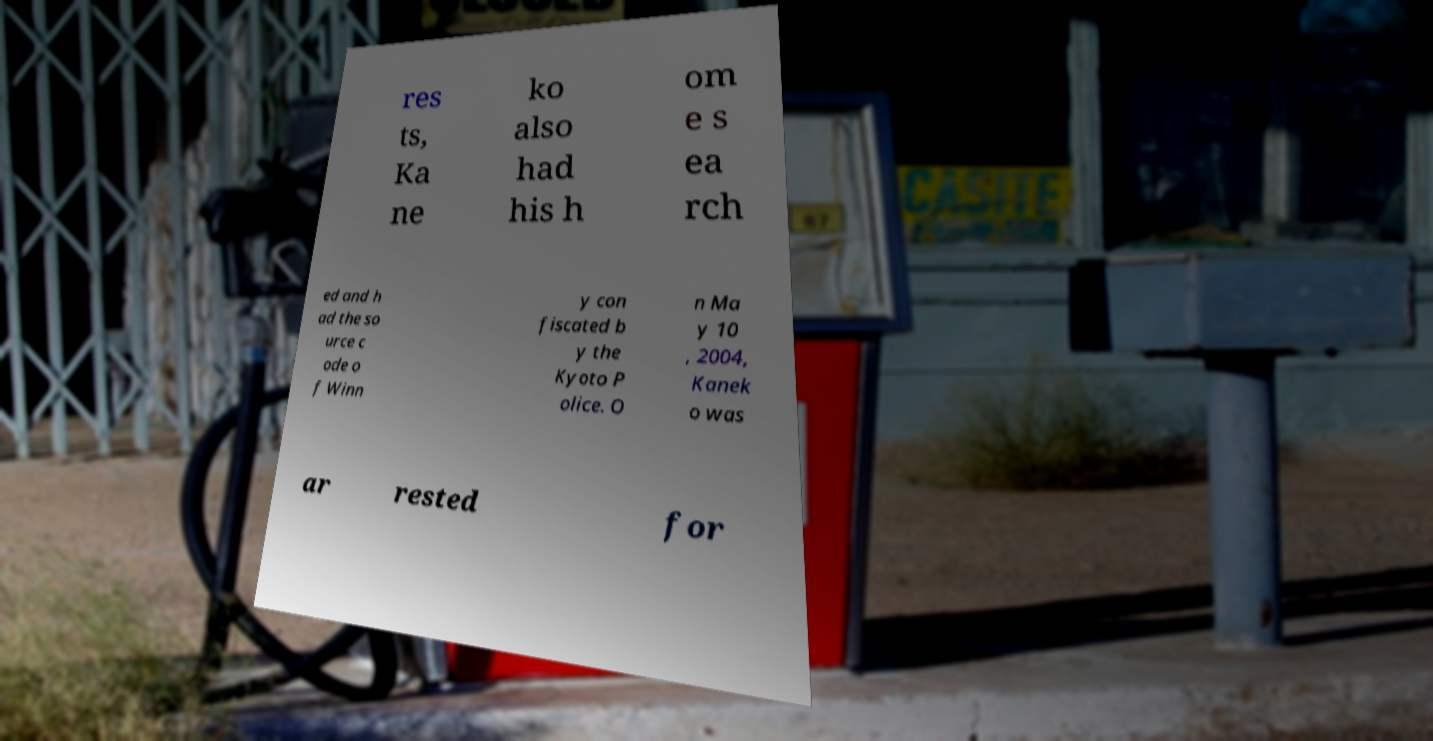Could you assist in decoding the text presented in this image and type it out clearly? res ts, Ka ne ko also had his h om e s ea rch ed and h ad the so urce c ode o f Winn y con fiscated b y the Kyoto P olice. O n Ma y 10 , 2004, Kanek o was ar rested for 